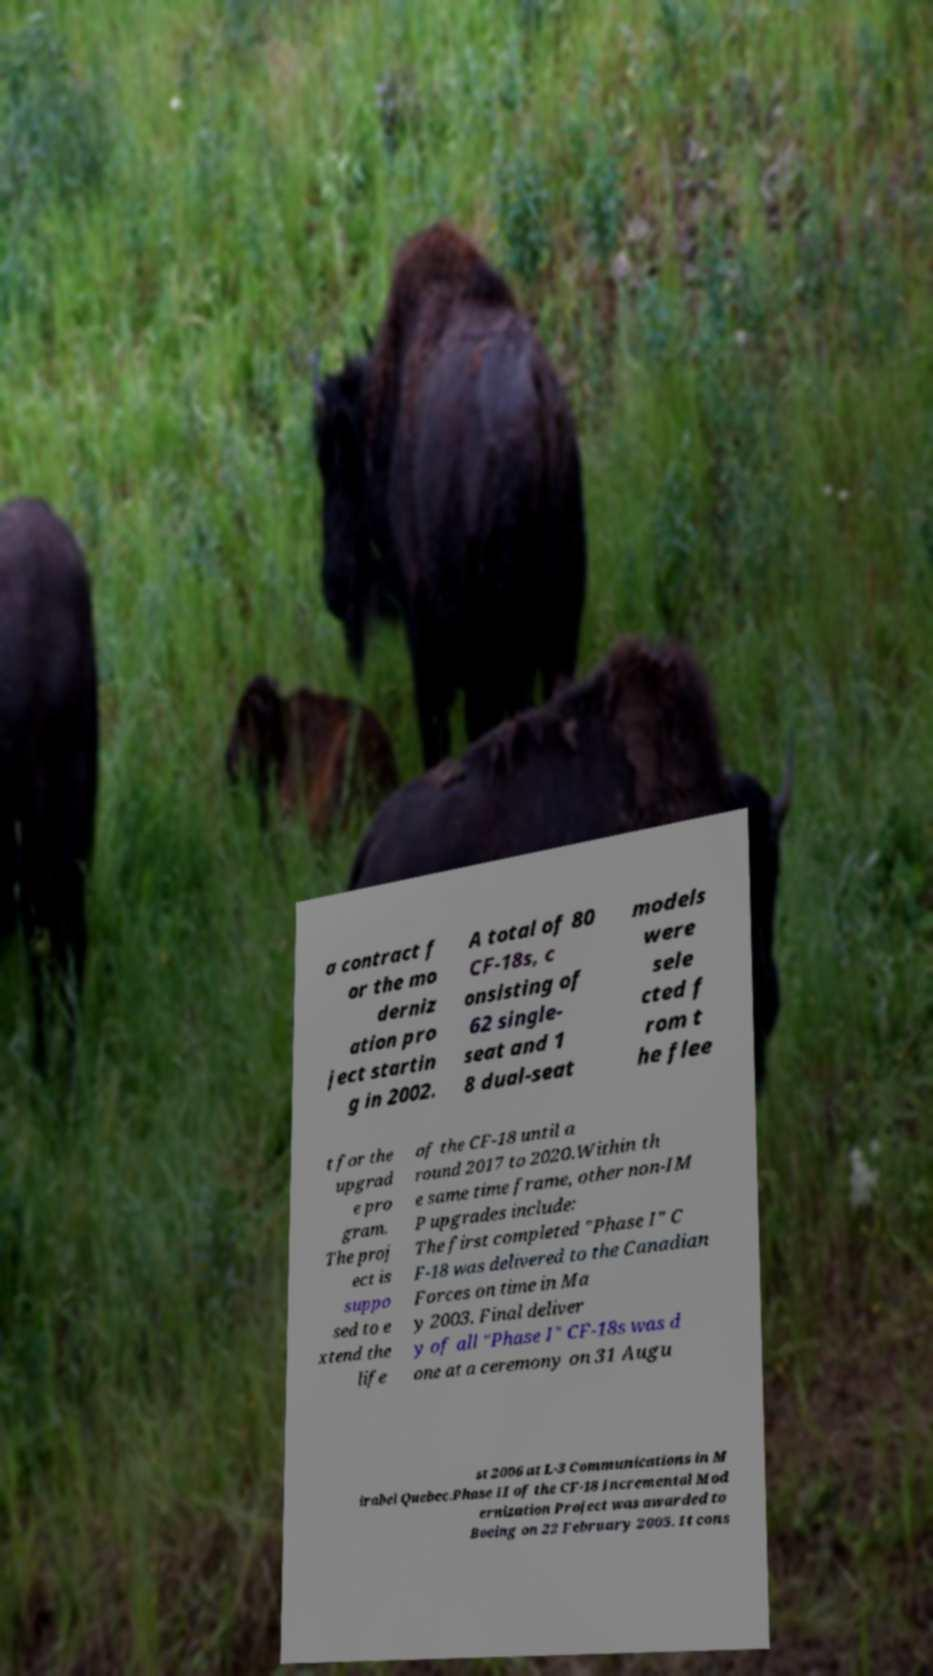Please read and relay the text visible in this image. What does it say? a contract f or the mo derniz ation pro ject startin g in 2002. A total of 80 CF-18s, c onsisting of 62 single- seat and 1 8 dual-seat models were sele cted f rom t he flee t for the upgrad e pro gram. The proj ect is suppo sed to e xtend the life of the CF-18 until a round 2017 to 2020.Within th e same time frame, other non-IM P upgrades include: The first completed "Phase I" C F-18 was delivered to the Canadian Forces on time in Ma y 2003. Final deliver y of all "Phase I" CF-18s was d one at a ceremony on 31 Augu st 2006 at L-3 Communications in M irabel Quebec.Phase II of the CF-18 Incremental Mod ernization Project was awarded to Boeing on 22 February 2005. It cons 